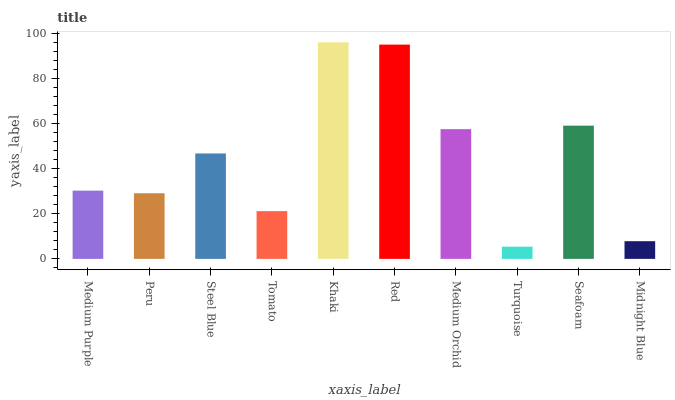Is Peru the minimum?
Answer yes or no. No. Is Peru the maximum?
Answer yes or no. No. Is Medium Purple greater than Peru?
Answer yes or no. Yes. Is Peru less than Medium Purple?
Answer yes or no. Yes. Is Peru greater than Medium Purple?
Answer yes or no. No. Is Medium Purple less than Peru?
Answer yes or no. No. Is Steel Blue the high median?
Answer yes or no. Yes. Is Medium Purple the low median?
Answer yes or no. Yes. Is Tomato the high median?
Answer yes or no. No. Is Peru the low median?
Answer yes or no. No. 